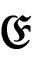<formula> <loc_0><loc_0><loc_500><loc_500>\mathfrak { E }</formula> 